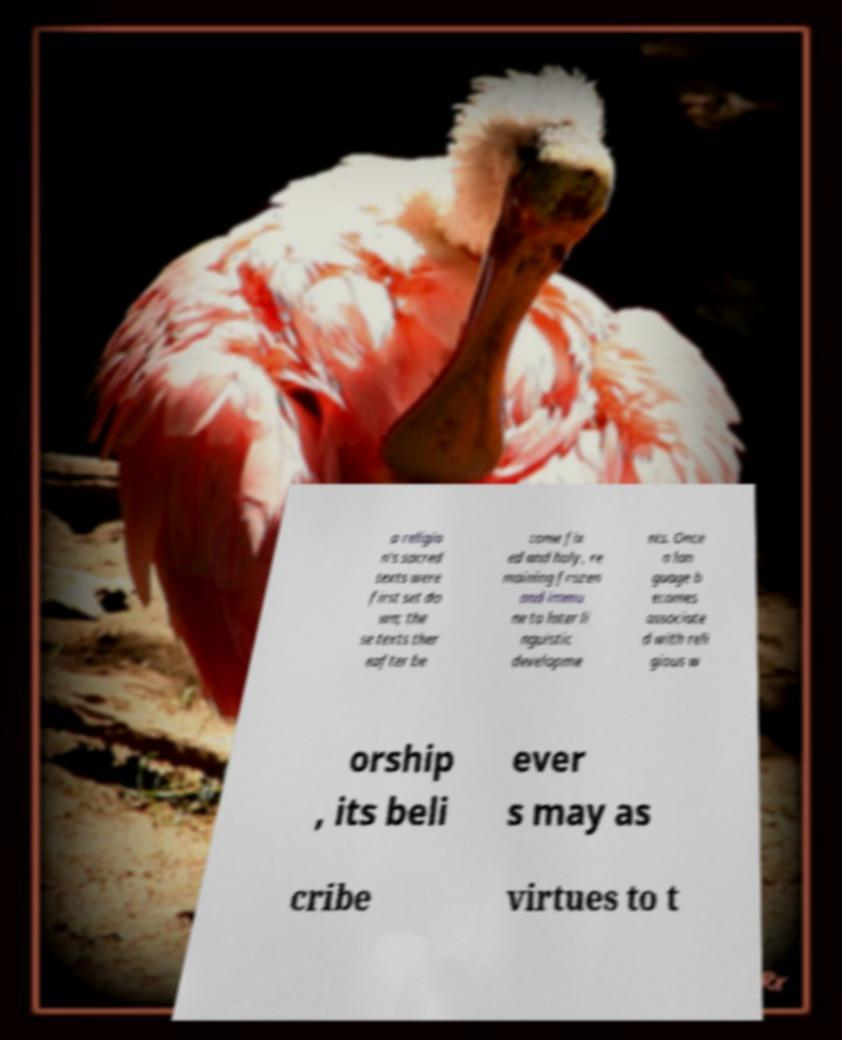Please read and relay the text visible in this image. What does it say? a religio n's sacred texts were first set do wn; the se texts ther eafter be come fix ed and holy, re maining frozen and immu ne to later li nguistic developme nts. Once a lan guage b ecomes associate d with reli gious w orship , its beli ever s may as cribe virtues to t 